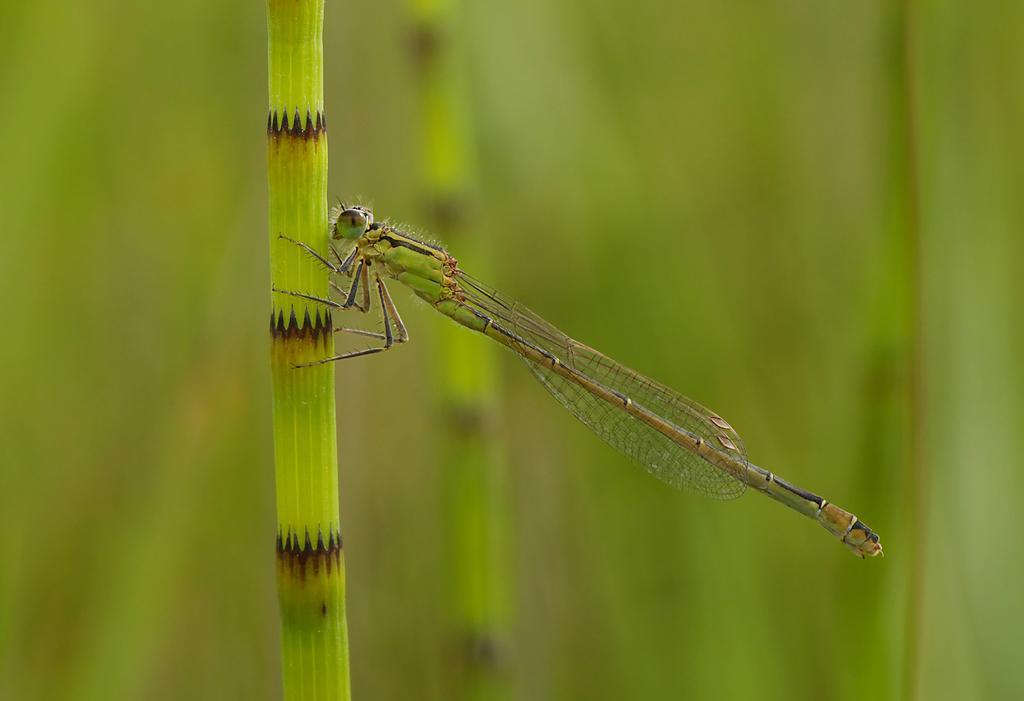Please provide a concise description of this image. In this image we can see an insect on the plant and the background is blurred. 